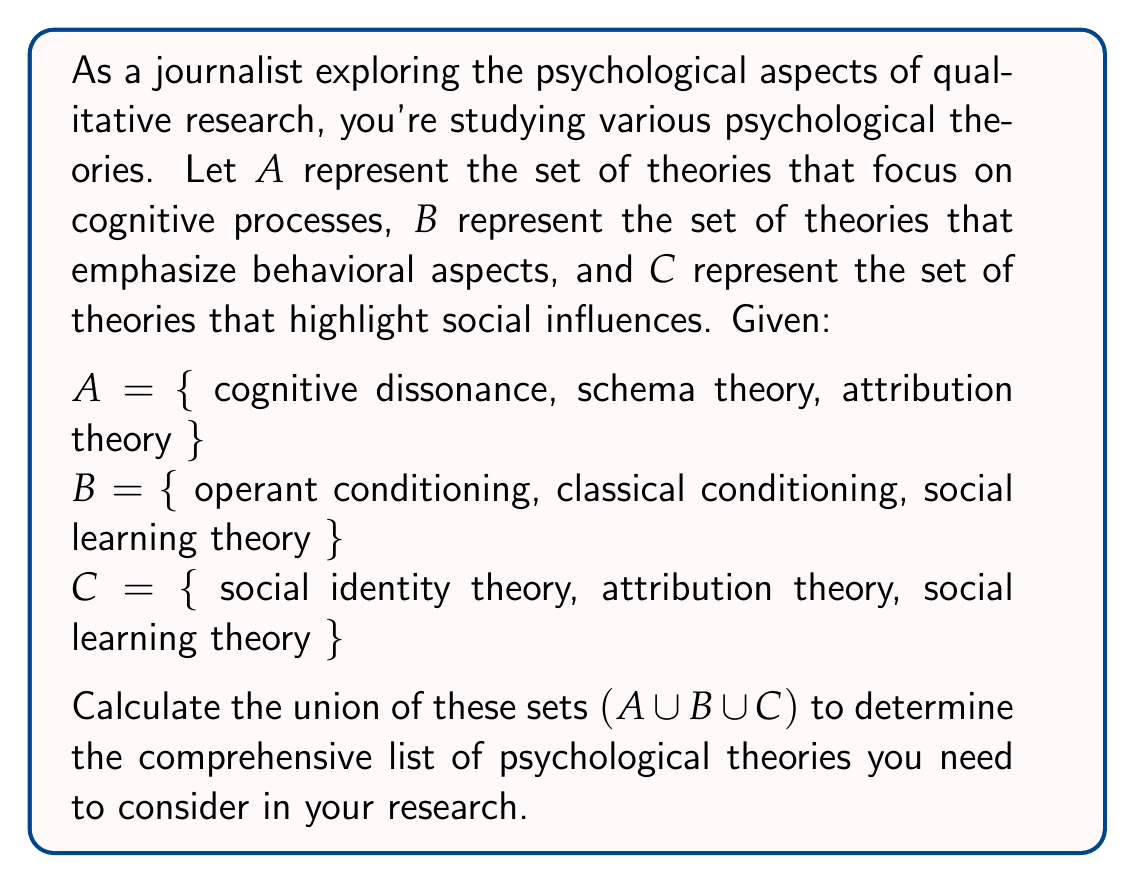Show me your answer to this math problem. To solve this problem, we need to understand the concept of union in set theory and apply it to the given sets. The union of sets includes all unique elements from all sets involved.

Let's break down the process step-by-step:

1. First, let's list all elements from set $A$:
   $\{$ cognitive dissonance, schema theory, attribution theory $\}$

2. Now, add any new elements from set $B$ that are not already included:
   $\{$ cognitive dissonance, schema theory, attribution theory, operant conditioning, classical conditioning, social learning theory $\}$

3. Finally, add any new elements from set $C$ that are not already in our list:
   $\{$ cognitive dissonance, schema theory, attribution theory, operant conditioning, classical conditioning, social learning theory, social identity theory $\}$

Note that we didn't add "attribution theory" and "social learning theory" again when considering set $C$, as they were already included from sets $A$ and $B$ respectively.

The resulting set is the union of $A$, $B$, and $C$, which we can write as $A \cup B \cup C$.

This process demonstrates how the union operation combines all unique elements from multiple sets, giving us a comprehensive list of psychological theories to consider in qualitative research.
Answer: $A \cup B \cup C = \{$ cognitive dissonance, schema theory, attribution theory, operant conditioning, classical conditioning, social learning theory, social identity theory $\}$ 